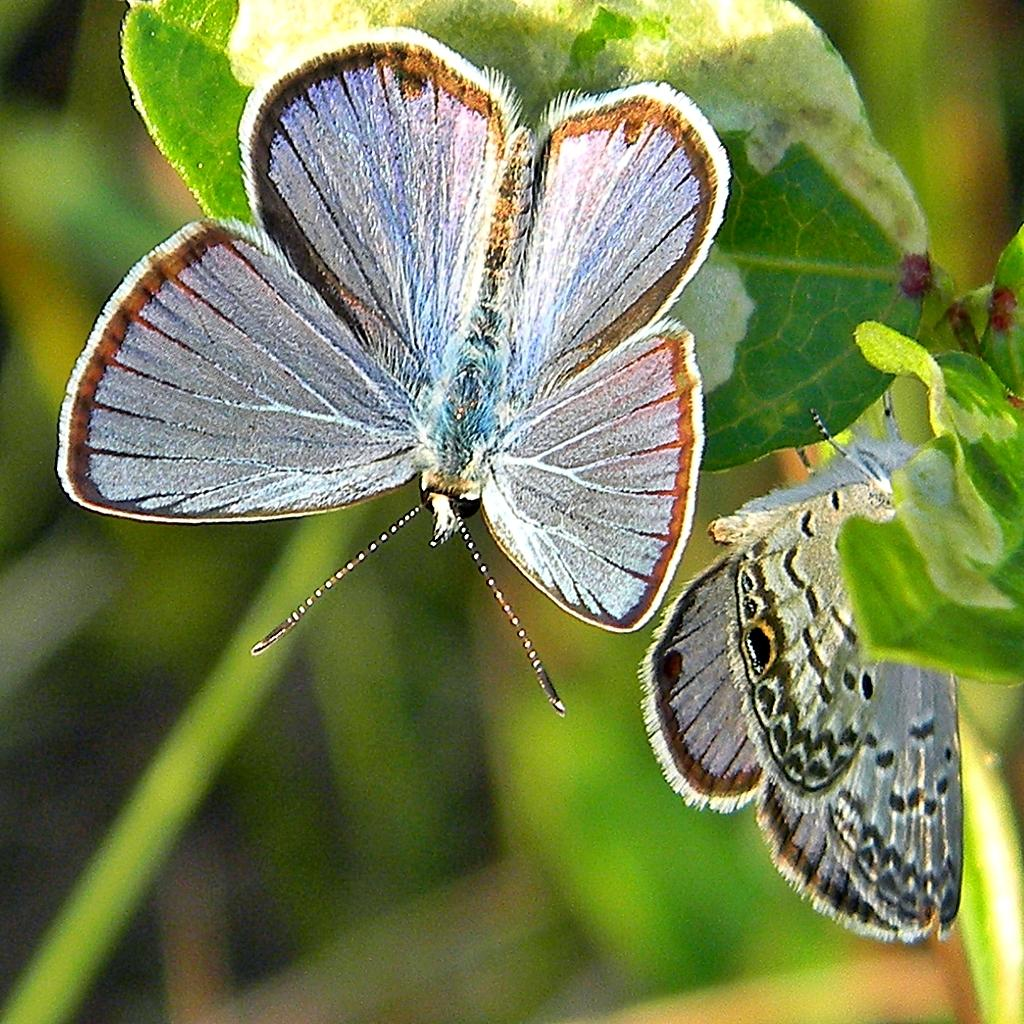What type of animals are in the image? There are butterflies in the image. What colors can be seen on the butterflies? The butterflies are in white and brown colors. Where are the butterflies located in the image? The butterflies are on leaves. What color is the background of the image? The background of the image is green. What religious verse can be seen written on the butterflies in the image? There is no religious verse present on the butterflies in the image; they are simply butterflies on leaves. 